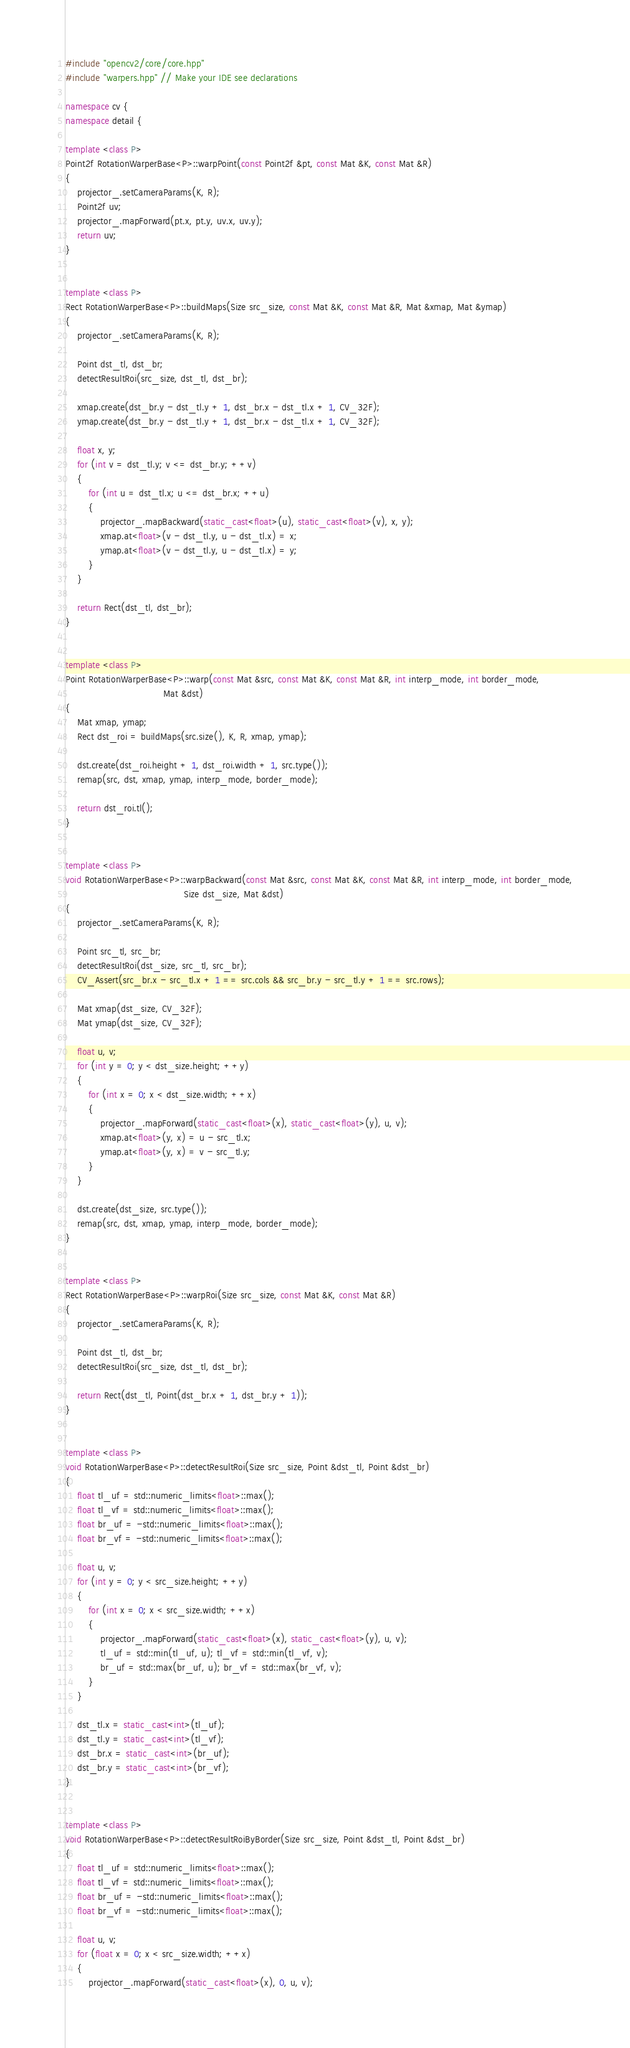Convert code to text. <code><loc_0><loc_0><loc_500><loc_500><_C++_>
#include "opencv2/core/core.hpp"
#include "warpers.hpp" // Make your IDE see declarations

namespace cv {
namespace detail {

template <class P>
Point2f RotationWarperBase<P>::warpPoint(const Point2f &pt, const Mat &K, const Mat &R)
{
    projector_.setCameraParams(K, R);
    Point2f uv;
    projector_.mapForward(pt.x, pt.y, uv.x, uv.y);
    return uv;
}


template <class P>
Rect RotationWarperBase<P>::buildMaps(Size src_size, const Mat &K, const Mat &R, Mat &xmap, Mat &ymap)
{
    projector_.setCameraParams(K, R);

    Point dst_tl, dst_br;
    detectResultRoi(src_size, dst_tl, dst_br);

    xmap.create(dst_br.y - dst_tl.y + 1, dst_br.x - dst_tl.x + 1, CV_32F);
    ymap.create(dst_br.y - dst_tl.y + 1, dst_br.x - dst_tl.x + 1, CV_32F);

    float x, y;
    for (int v = dst_tl.y; v <= dst_br.y; ++v)
    {
        for (int u = dst_tl.x; u <= dst_br.x; ++u)
        {
            projector_.mapBackward(static_cast<float>(u), static_cast<float>(v), x, y);
            xmap.at<float>(v - dst_tl.y, u - dst_tl.x) = x;
            ymap.at<float>(v - dst_tl.y, u - dst_tl.x) = y;
        }
    }

    return Rect(dst_tl, dst_br);
}


template <class P>
Point RotationWarperBase<P>::warp(const Mat &src, const Mat &K, const Mat &R, int interp_mode, int border_mode,
                                  Mat &dst)
{
    Mat xmap, ymap;
    Rect dst_roi = buildMaps(src.size(), K, R, xmap, ymap);

    dst.create(dst_roi.height + 1, dst_roi.width + 1, src.type());
    remap(src, dst, xmap, ymap, interp_mode, border_mode);

    return dst_roi.tl();
}


template <class P>
void RotationWarperBase<P>::warpBackward(const Mat &src, const Mat &K, const Mat &R, int interp_mode, int border_mode,
                                         Size dst_size, Mat &dst)
{
    projector_.setCameraParams(K, R);

    Point src_tl, src_br;
    detectResultRoi(dst_size, src_tl, src_br);
    CV_Assert(src_br.x - src_tl.x + 1 == src.cols && src_br.y - src_tl.y + 1 == src.rows);

    Mat xmap(dst_size, CV_32F);
    Mat ymap(dst_size, CV_32F);

    float u, v;
    for (int y = 0; y < dst_size.height; ++y)
    {
        for (int x = 0; x < dst_size.width; ++x)
        {
            projector_.mapForward(static_cast<float>(x), static_cast<float>(y), u, v);
            xmap.at<float>(y, x) = u - src_tl.x;
            ymap.at<float>(y, x) = v - src_tl.y;
        }
    }

    dst.create(dst_size, src.type());
    remap(src, dst, xmap, ymap, interp_mode, border_mode);
}


template <class P>
Rect RotationWarperBase<P>::warpRoi(Size src_size, const Mat &K, const Mat &R)
{
    projector_.setCameraParams(K, R);

    Point dst_tl, dst_br;
    detectResultRoi(src_size, dst_tl, dst_br);

    return Rect(dst_tl, Point(dst_br.x + 1, dst_br.y + 1));
}


template <class P>
void RotationWarperBase<P>::detectResultRoi(Size src_size, Point &dst_tl, Point &dst_br)
{
    float tl_uf = std::numeric_limits<float>::max();
    float tl_vf = std::numeric_limits<float>::max();
    float br_uf = -std::numeric_limits<float>::max();
    float br_vf = -std::numeric_limits<float>::max();

    float u, v;
    for (int y = 0; y < src_size.height; ++y)
    {
        for (int x = 0; x < src_size.width; ++x)
        {
            projector_.mapForward(static_cast<float>(x), static_cast<float>(y), u, v);
            tl_uf = std::min(tl_uf, u); tl_vf = std::min(tl_vf, v);
            br_uf = std::max(br_uf, u); br_vf = std::max(br_vf, v);
        }
    }

    dst_tl.x = static_cast<int>(tl_uf);
    dst_tl.y = static_cast<int>(tl_vf);
    dst_br.x = static_cast<int>(br_uf);
    dst_br.y = static_cast<int>(br_vf);
}


template <class P>
void RotationWarperBase<P>::detectResultRoiByBorder(Size src_size, Point &dst_tl, Point &dst_br)
{
    float tl_uf = std::numeric_limits<float>::max();
    float tl_vf = std::numeric_limits<float>::max();
    float br_uf = -std::numeric_limits<float>::max();
    float br_vf = -std::numeric_limits<float>::max();

    float u, v;
    for (float x = 0; x < src_size.width; ++x)
    {
        projector_.mapForward(static_cast<float>(x), 0, u, v);</code> 